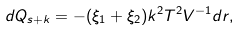Convert formula to latex. <formula><loc_0><loc_0><loc_500><loc_500>d Q _ { s + k } = - ( \xi _ { 1 } + \xi _ { 2 } ) k ^ { 2 } T ^ { 2 } V ^ { - 1 } d r ,</formula> 